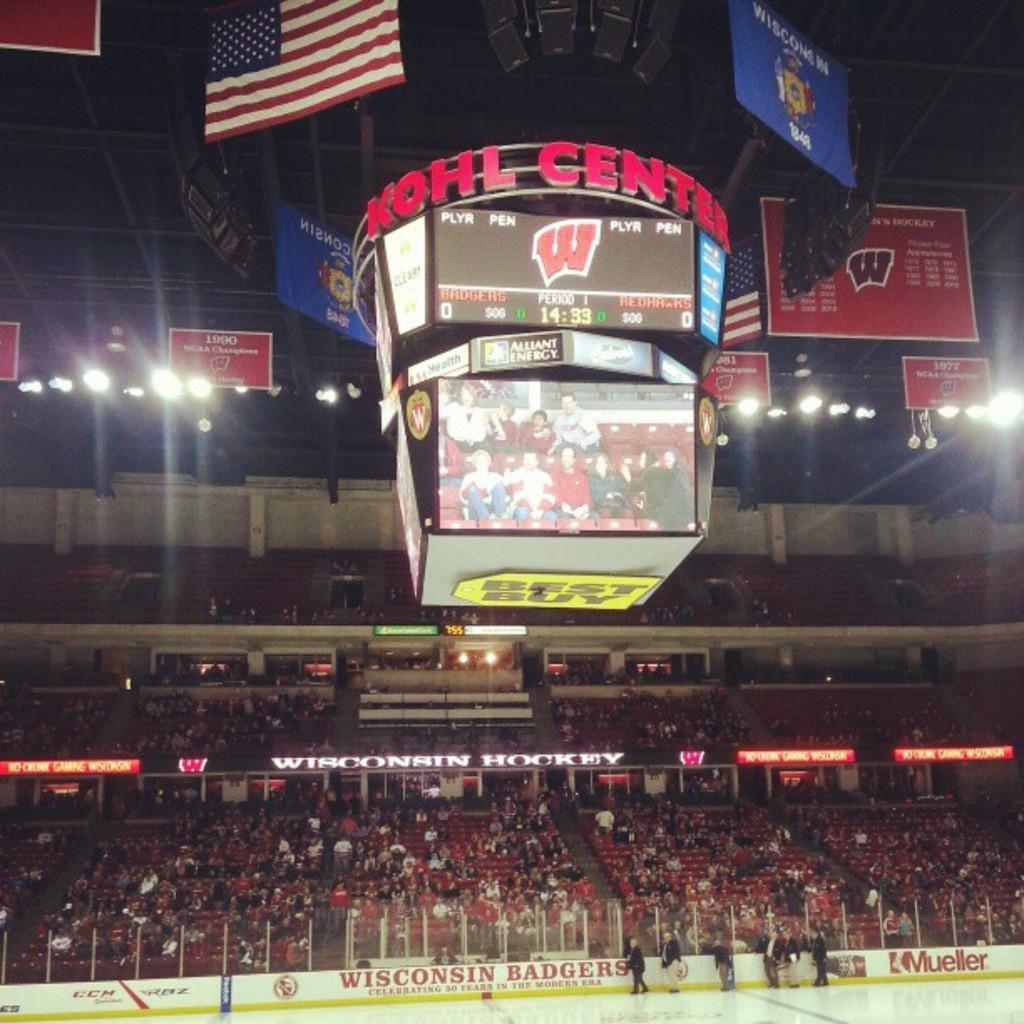<image>
Relay a brief, clear account of the picture shown. The big screen at the Kohl Center has a Best Buy advertisement on the bottom of it. 